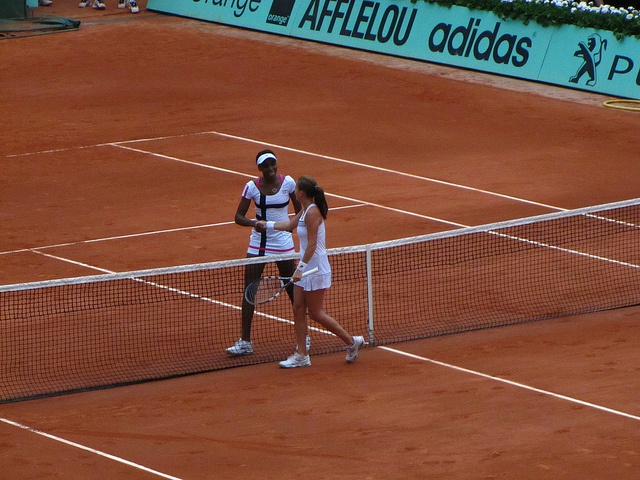Describe the objects in this image and their specific colors. I can see people in black, maroon, gray, and darkgray tones, people in black, darkgray, gray, and maroon tones, and tennis racket in black, brown, and maroon tones in this image. 